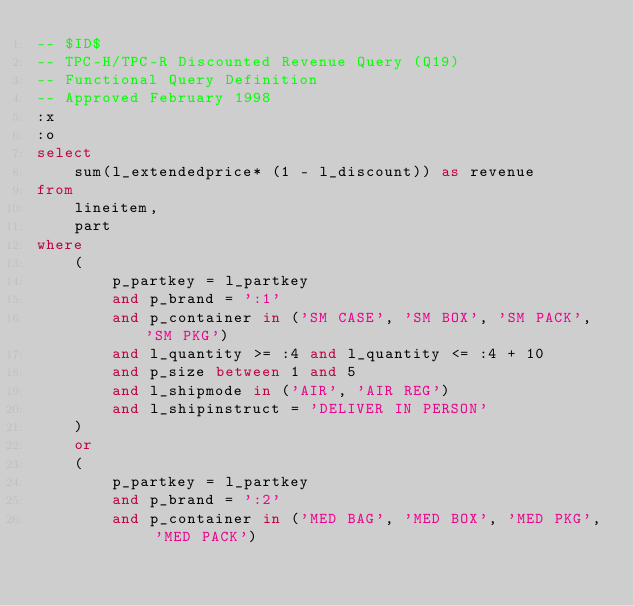Convert code to text. <code><loc_0><loc_0><loc_500><loc_500><_SQL_>-- $ID$
-- TPC-H/TPC-R Discounted Revenue Query (Q19)
-- Functional Query Definition
-- Approved February 1998
:x
:o
select
	sum(l_extendedprice* (1 - l_discount)) as revenue
from
	lineitem,
	part
where
	(
		p_partkey = l_partkey
		and p_brand = ':1'
		and p_container in ('SM CASE', 'SM BOX', 'SM PACK', 'SM PKG')
		and l_quantity >= :4 and l_quantity <= :4 + 10
		and p_size between 1 and 5
		and l_shipmode in ('AIR', 'AIR REG')
		and l_shipinstruct = 'DELIVER IN PERSON'
	)
	or
	(
		p_partkey = l_partkey
		and p_brand = ':2'
		and p_container in ('MED BAG', 'MED BOX', 'MED PKG', 'MED PACK')</code> 